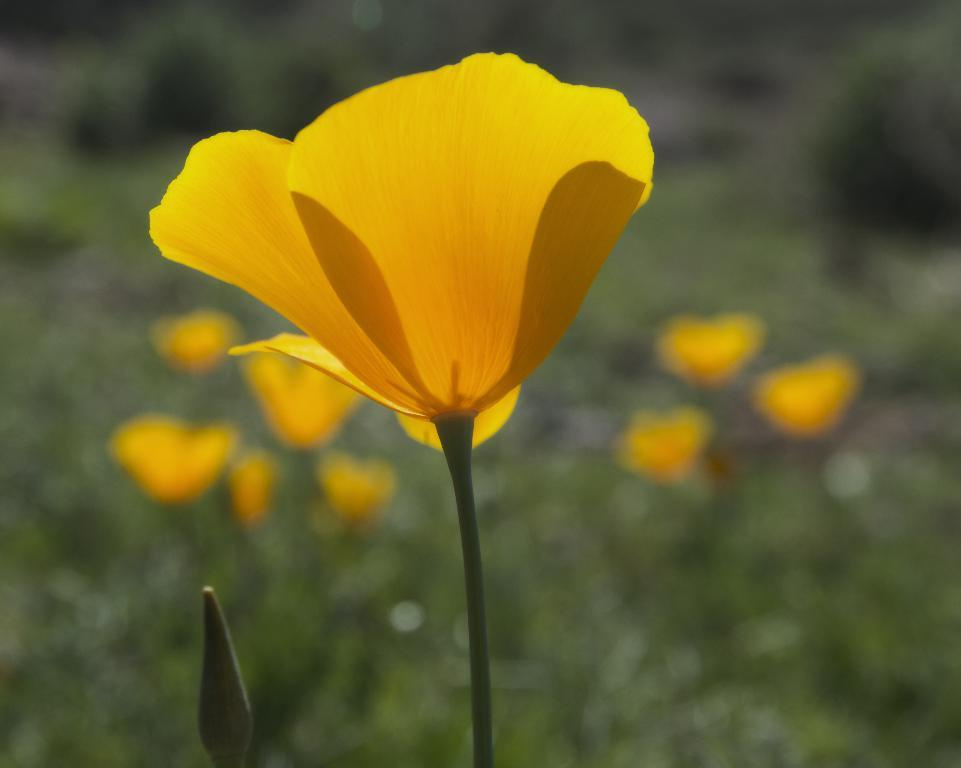What type of plant is shown in the image? There is a flower bud and a flower with a stem in the image. What can be seen in the background of the image? The background of the image is blurred. What else is visible in the image besides the flower? Flower plants and greenery are present in the image. How many trucks are parked near the flower in the image? There are no trucks present in the image; it features a flower bud, a flower with a stem, and greenery. What stage of development is the tooth in the image? There is no tooth present in the image; it focuses on a flower bud, a flower with a stem, and greenery. 